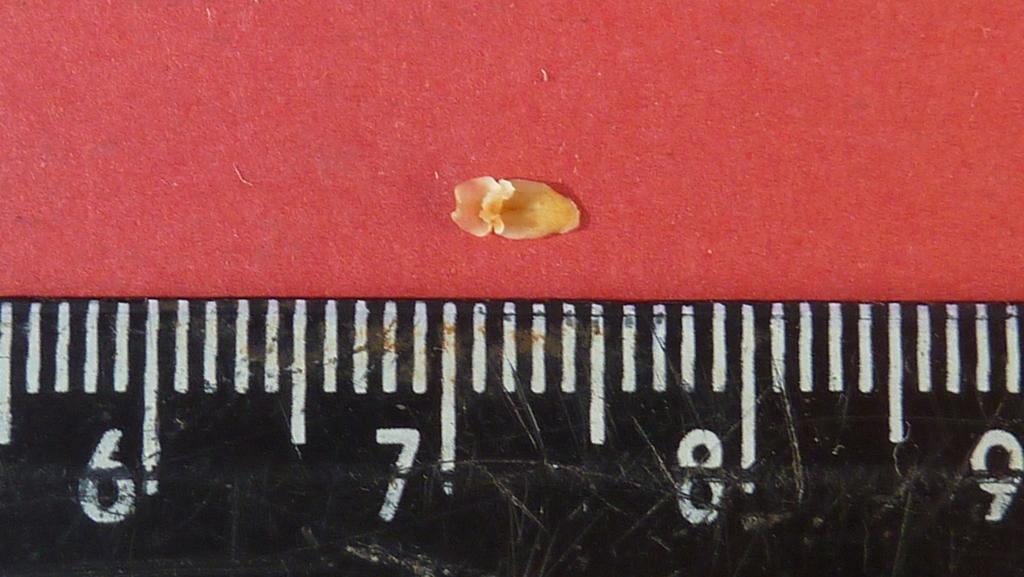What is the large number under the object being measured?
Keep it short and to the point. 7. What is the most left number?
Provide a succinct answer. 6. 